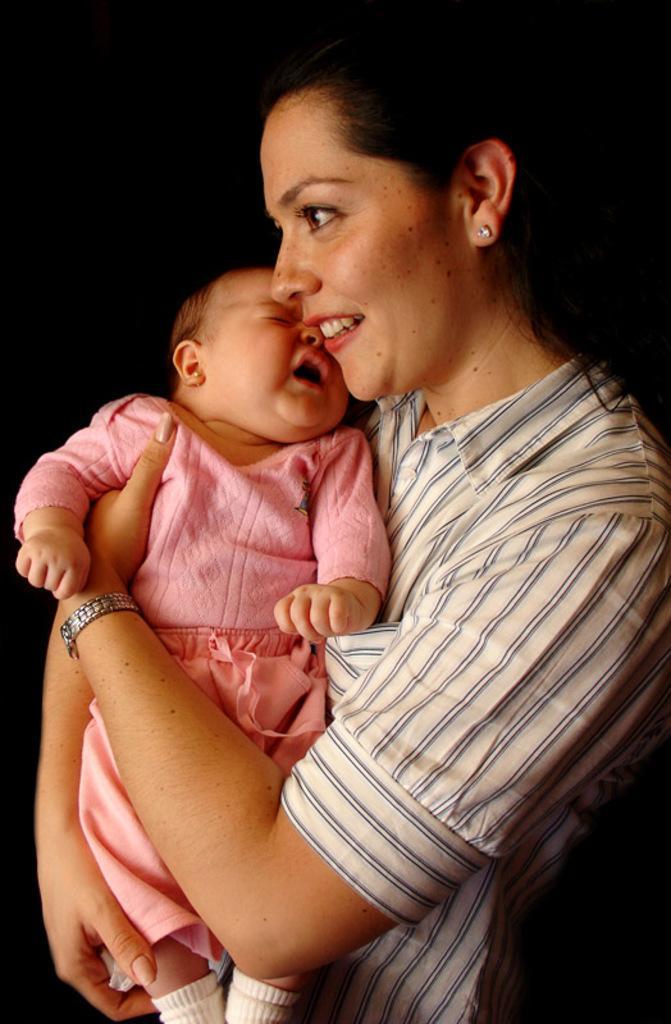Can you describe this image briefly? In the picture I can see a woman is carrying a child. The child is wearing pink color clothes. The woman is wearing a watch. The woman is smiling. The background of the image is dark. 